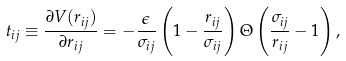Convert formula to latex. <formula><loc_0><loc_0><loc_500><loc_500>t _ { i j } \equiv \frac { { \partial V ( r _ { i j } ) } } { { \partial r _ { i j } } } = - \frac { \epsilon } { \sigma _ { i j } } \left ( 1 - \frac { { r _ { i j } } } { { \sigma _ { i j } } } \right ) \Theta \left ( \frac { { \sigma _ { i j } } } { { r _ { i j } } } - 1 \right ) ,</formula> 